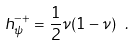Convert formula to latex. <formula><loc_0><loc_0><loc_500><loc_500>h _ { \psi } ^ { - + } = \frac { 1 } { 2 } \nu ( 1 - \nu ) \ .</formula> 